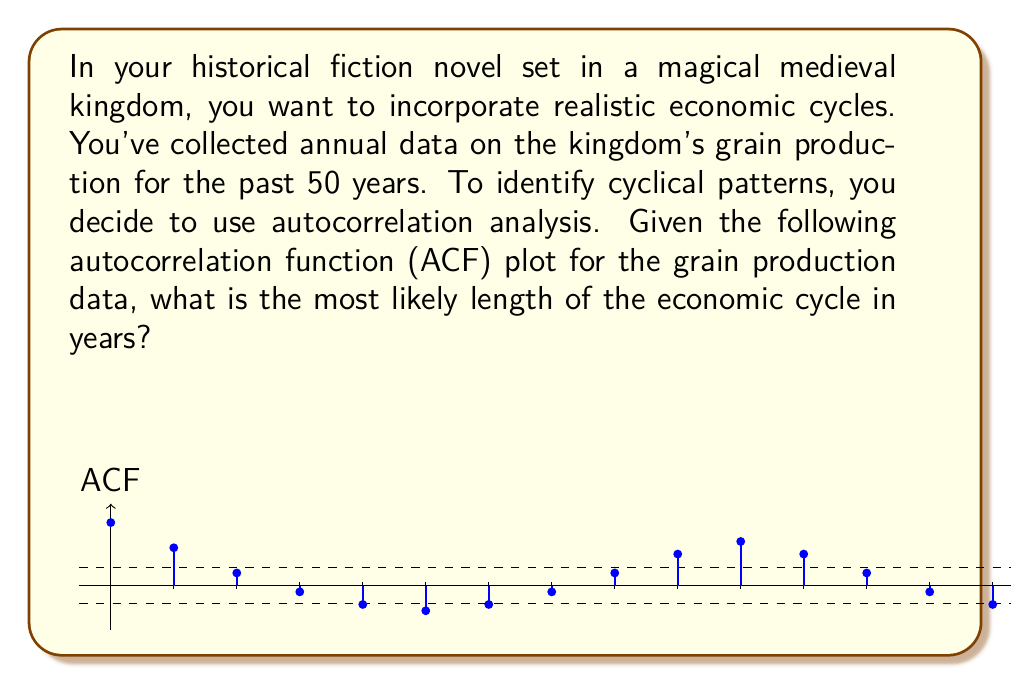Provide a solution to this math problem. To identify the cyclical pattern in the grain production data using the autocorrelation function (ACF) plot, we need to follow these steps:

1. Understand the ACF plot:
   - The x-axis represents the lag (in years).
   - The y-axis represents the autocorrelation coefficient.
   - The dashed lines represent the approximate 95% confidence interval.

2. Identify significant autocorrelations:
   - Autocorrelations outside the dashed lines are considered statistically significant.
   - We observe significant positive autocorrelations at lags 1, 2, 10, and 11.
   - We observe significant negative autocorrelations at lags 5, 6, and 7.

3. Look for repeating patterns:
   - The ACF plot shows a wave-like pattern that repeats.
   - The pattern starts positive, becomes negative, and then becomes positive again.

4. Determine the cycle length:
   - The cycle length is the distance between peaks in the ACF plot.
   - We observe peaks at lag 0 and lag 11.
   - The distance between these peaks is 11 lags.

5. Interpret the result:
   - A peak at lag 11 suggests that the data values are most similar to values 11 years apart.
   - This indicates a cyclical pattern that repeats approximately every 11 years.

Therefore, based on the ACF plot, the most likely length of the economic cycle in the kingdom's grain production is 11 years.
Answer: 11 years 